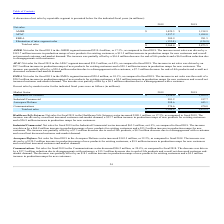From Plexus's financial document, Which years does the table provide information for net sales by reportable segment? The document shows two values: 2019 and 2018. From the document: "2019 2018 2019 2018..." Also, What was the net sales from AMER in 2018? According to the financial document, 1,218.9 (in millions). The relevant text states: "AMER $ 1,429.3 $ 1,218.9..." Also, What was the net sales from EMEA in 2019? According to the financial document, 309.9 (in millions). The relevant text states: "EMEA 309.9 281.5..." Also, How many years did net sales from APAC exceed $1,500 million? Based on the analysis, there are 1 instances. The counting process: 2019. Also, can you calculate: What was the difference in net sales in 2018 between AMER and EMEA regions? Based on the calculation: 1,218.9-281.5, the result is 937.4 (in millions). This is based on the information: "EMEA 309.9 281.5 AMER $ 1,429.3 $ 1,218.9..." The key data points involved are: 1,218.9, 281.5. Also, can you calculate: What was the percentage change in the Elimination of inter-segment sales between 2018 and 2019? To answer this question, I need to perform calculations using the financial data. The calculation is: (-132.0-(-124.9))/-124.9, which equals 5.68 (percentage). This is based on the information: "Elimination of inter-segment sales (132.0) (124.9) Elimination of inter-segment sales (132.0) (124.9)..." The key data points involved are: 124.9, 132.0. 